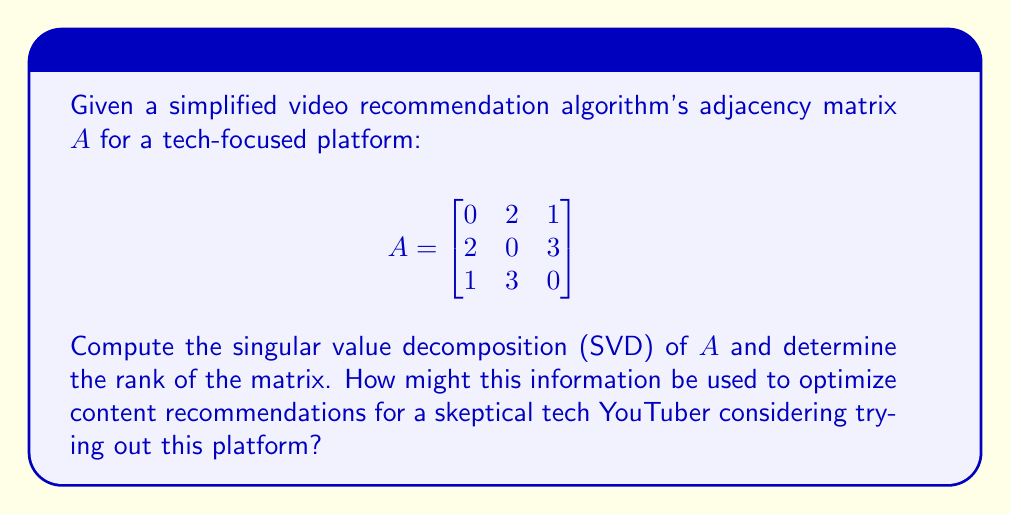Show me your answer to this math problem. To find the singular value decomposition (SVD) of matrix $A$, we need to find matrices $U$, $\Sigma$, and $V^T$ such that $A = U\Sigma V^T$.

Step 1: Calculate $A^TA$ and $AA^T$:

$$A^TA = \begin{bmatrix}
5 & 6 & 5 \\
6 & 13 & 9 \\
5 & 9 & 10
\end{bmatrix}$$

$$AA^T = \begin{bmatrix}
5 & 6 & 5 \\
6 & 13 & 9 \\
5 & 9 & 10
\end{bmatrix}$$

Step 2: Find eigenvalues of $A^TA$ (or $AA^T$):
Characteristic equation: $\det(A^TA - \lambda I) = 0$
Solving this equation yields eigenvalues: $\lambda_1 \approx 23.35$, $\lambda_2 \approx 4.65$, $\lambda_3 = 0$

Step 3: Calculate singular values:
$\sigma_i = \sqrt{\lambda_i}$
$\sigma_1 \approx 4.83$, $\sigma_2 \approx 2.16$, $\sigma_3 = 0$

Step 4: Find eigenvectors of $A^TA$ and $AA^T$ to form $V$ and $U$ respectively:

$$V \approx \begin{bmatrix}
-0.34 & -0.67 & 0.66 \\
-0.76 & 0.18 & -0.62 \\
-0.55 & 0.72 & 0.42
\end{bmatrix}$$

$$U \approx \begin{bmatrix}
-0.34 & -0.67 & 0.66 \\
-0.76 & 0.18 & -0.62 \\
-0.55 & 0.72 & 0.42
\end{bmatrix}$$

Step 5: Form the SVD:

$$A = U\Sigma V^T \approx \begin{bmatrix}
-0.34 & -0.67 & 0.66 \\
-0.76 & 0.18 & -0.62 \\
-0.55 & 0.72 & 0.42
\end{bmatrix}
\begin{bmatrix}
4.83 & 0 & 0 \\
0 & 2.16 & 0 \\
0 & 0 & 0
\end{bmatrix}
\begin{bmatrix}
-0.34 & -0.76 & -0.55 \\
-0.67 & 0.18 & 0.72 \\
0.66 & -0.62 & 0.42
\end{bmatrix}$$

The rank of matrix $A$ is equal to the number of non-zero singular values, which is 2.

For a skeptical tech YouTuber, this SVD can be used to optimize content recommendations by:
1. Dimensionality reduction: Using only the top 2 singular values and corresponding singular vectors to approximate the recommendation system, reducing complexity.
2. Identifying key features: The columns of $U$ corresponding to the largest singular values represent the most important features in video recommendations.
3. User-item interactions: The singular values indicate the strength of different recommendation patterns, which can be used to tailor content to the YouTuber's preferences while introducing them to new, relevant content on the platform.
Answer: SVD: $A \approx U\Sigma V^T$, where $U$ and $V$ are 3x3 orthogonal matrices, and $\Sigma = \text{diag}(4.83, 2.16, 0)$. Rank: 2. 